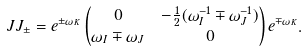Convert formula to latex. <formula><loc_0><loc_0><loc_500><loc_500>\ J J _ { \pm } & = e ^ { \pm \omega _ { K } } \left ( \begin{matrix} 0 & - \frac { 1 } { 2 } ( \omega _ { I } ^ { - 1 } \mp \omega _ { J } ^ { - 1 } ) \\ \omega _ { I } \mp \omega _ { J } & 0 \end{matrix} \right ) e ^ { \mp \omega _ { K } } .</formula> 